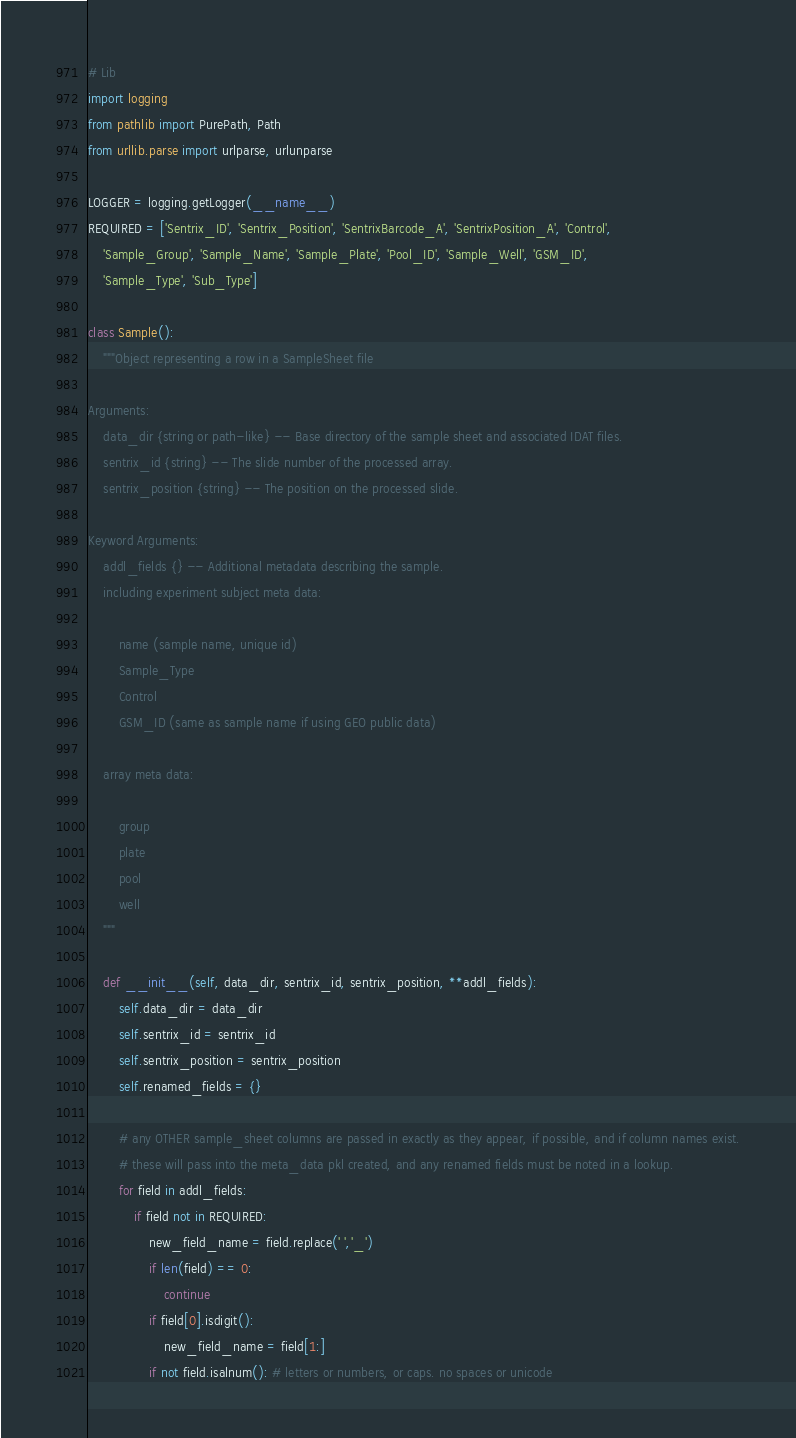Convert code to text. <code><loc_0><loc_0><loc_500><loc_500><_Python_># Lib
import logging
from pathlib import PurePath, Path
from urllib.parse import urlparse, urlunparse

LOGGER = logging.getLogger(__name__)
REQUIRED = ['Sentrix_ID', 'Sentrix_Position', 'SentrixBarcode_A', 'SentrixPosition_A', 'Control',
    'Sample_Group', 'Sample_Name', 'Sample_Plate', 'Pool_ID', 'Sample_Well', 'GSM_ID',
    'Sample_Type', 'Sub_Type']

class Sample():
    """Object representing a row in a SampleSheet file

Arguments:
    data_dir {string or path-like} -- Base directory of the sample sheet and associated IDAT files.
    sentrix_id {string} -- The slide number of the processed array.
    sentrix_position {string} -- The position on the processed slide.

Keyword Arguments:
    addl_fields {} -- Additional metadata describing the sample.
    including experiment subject meta data:

        name (sample name, unique id)
        Sample_Type
        Control
        GSM_ID (same as sample name if using GEO public data)

    array meta data:

        group
        plate
        pool
        well
    """

    def __init__(self, data_dir, sentrix_id, sentrix_position, **addl_fields):
        self.data_dir = data_dir
        self.sentrix_id = sentrix_id
        self.sentrix_position = sentrix_position
        self.renamed_fields = {}

        # any OTHER sample_sheet columns are passed in exactly as they appear, if possible, and if column names exist.
        # these will pass into the meta_data pkl created, and any renamed fields must be noted in a lookup.
        for field in addl_fields:
            if field not in REQUIRED:
                new_field_name = field.replace(' ','_')
                if len(field) == 0:
                    continue
                if field[0].isdigit():
                    new_field_name = field[1:]
                if not field.isalnum(): # letters or numbers, or caps. no spaces or unicode</code> 